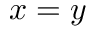<formula> <loc_0><loc_0><loc_500><loc_500>x = y</formula> 